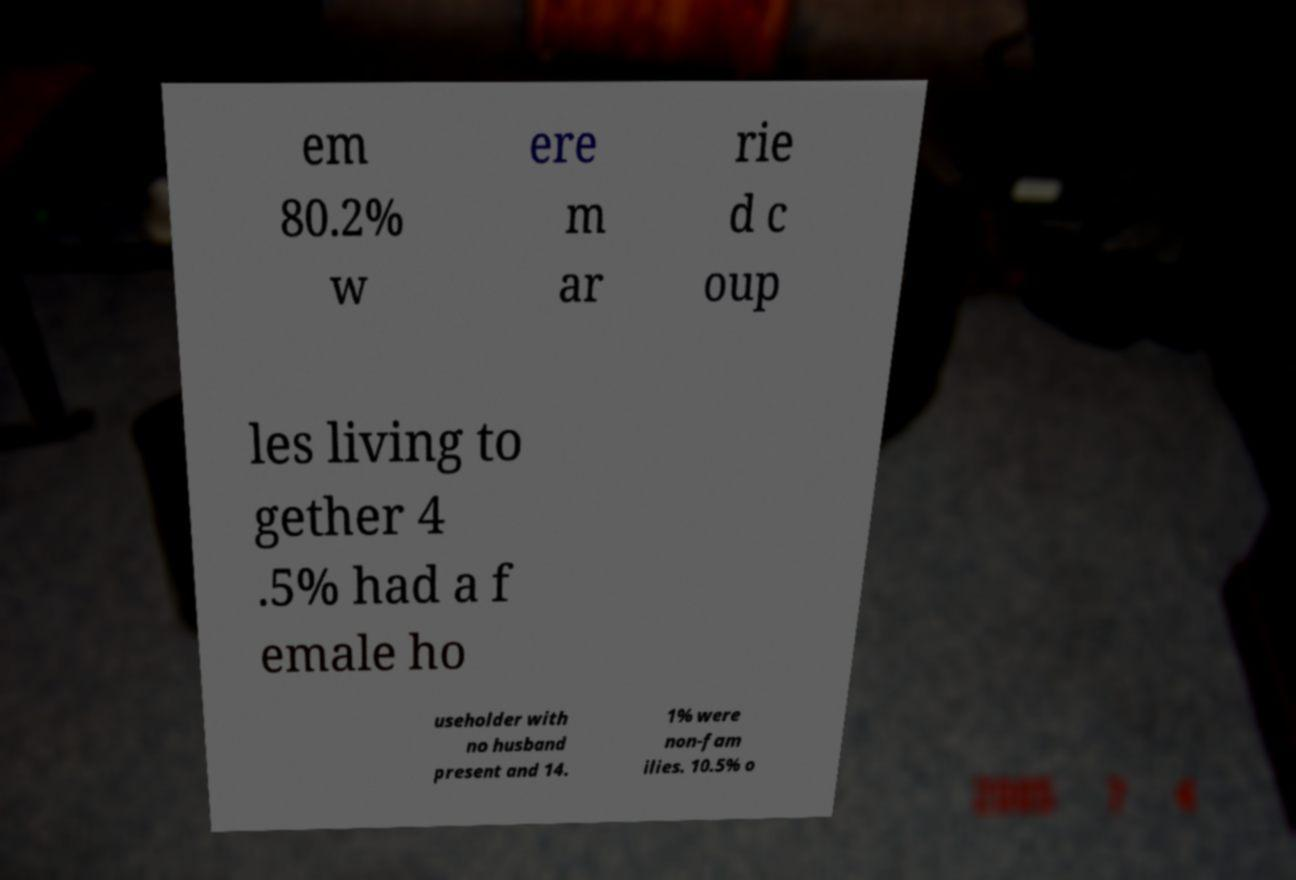Could you assist in decoding the text presented in this image and type it out clearly? em 80.2% w ere m ar rie d c oup les living to gether 4 .5% had a f emale ho useholder with no husband present and 14. 1% were non-fam ilies. 10.5% o 